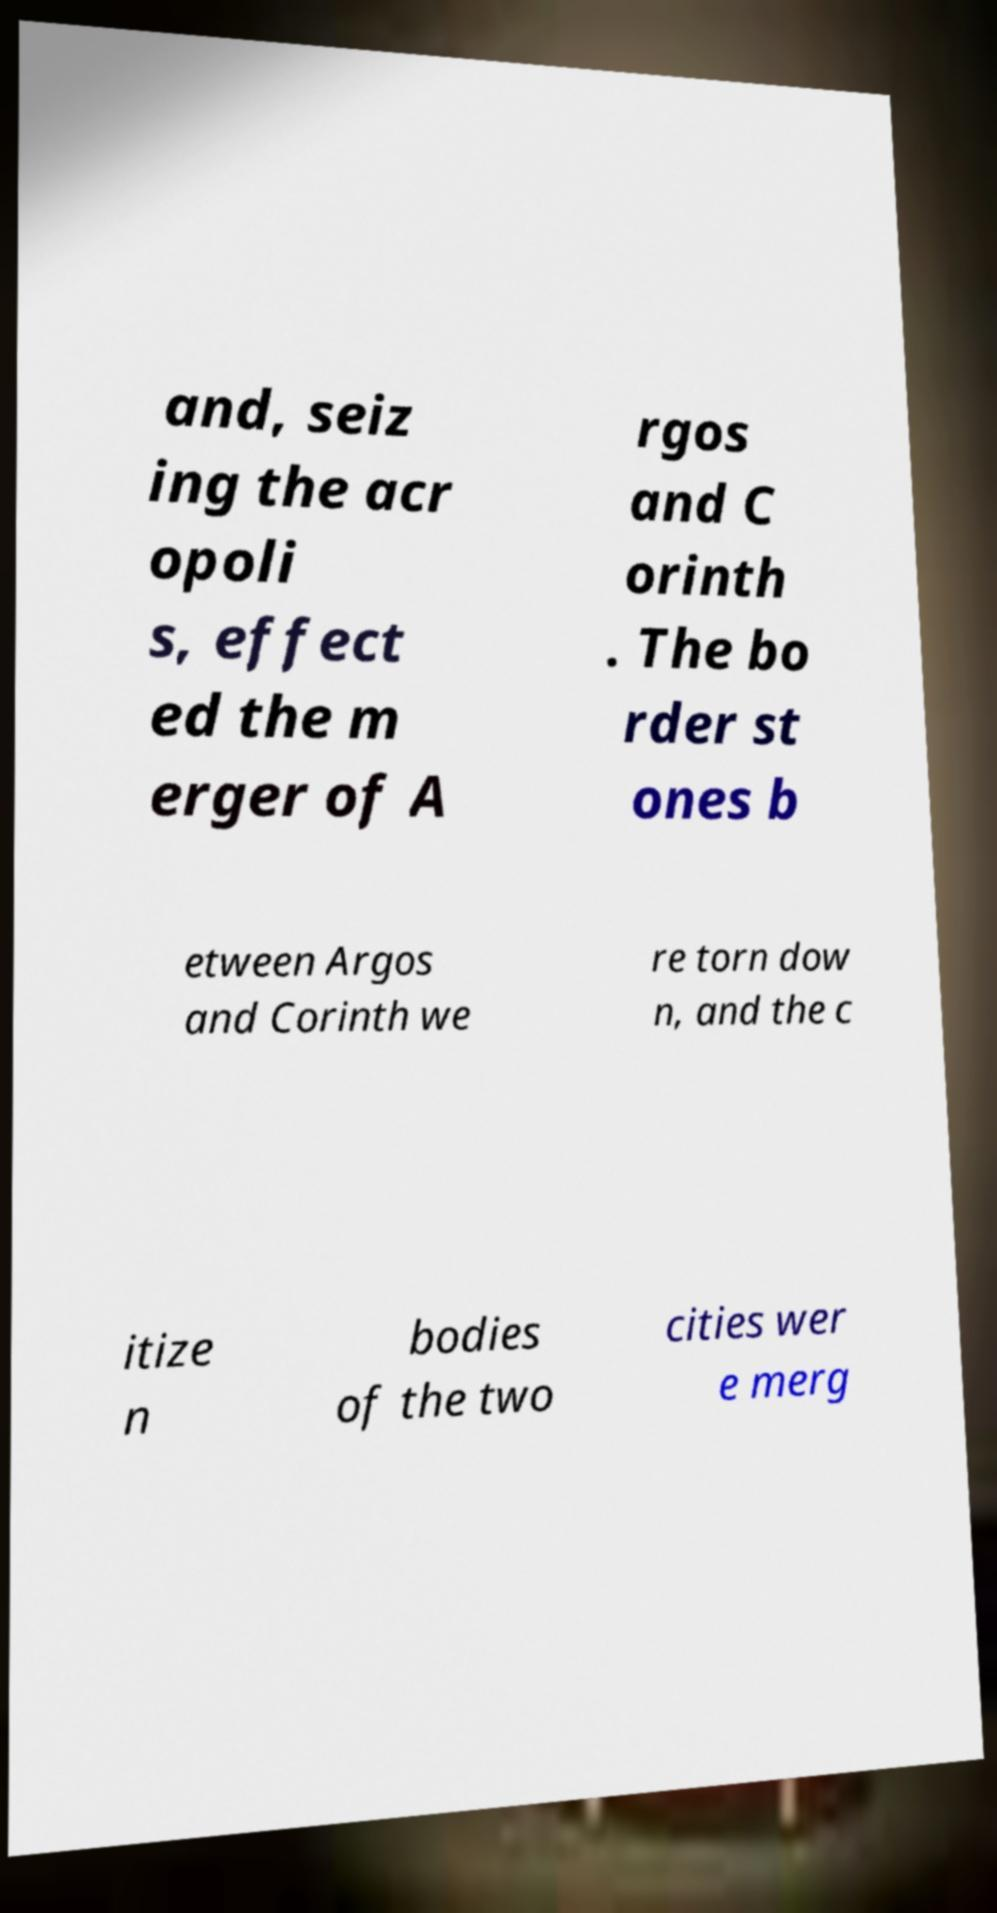Could you extract and type out the text from this image? and, seiz ing the acr opoli s, effect ed the m erger of A rgos and C orinth . The bo rder st ones b etween Argos and Corinth we re torn dow n, and the c itize n bodies of the two cities wer e merg 